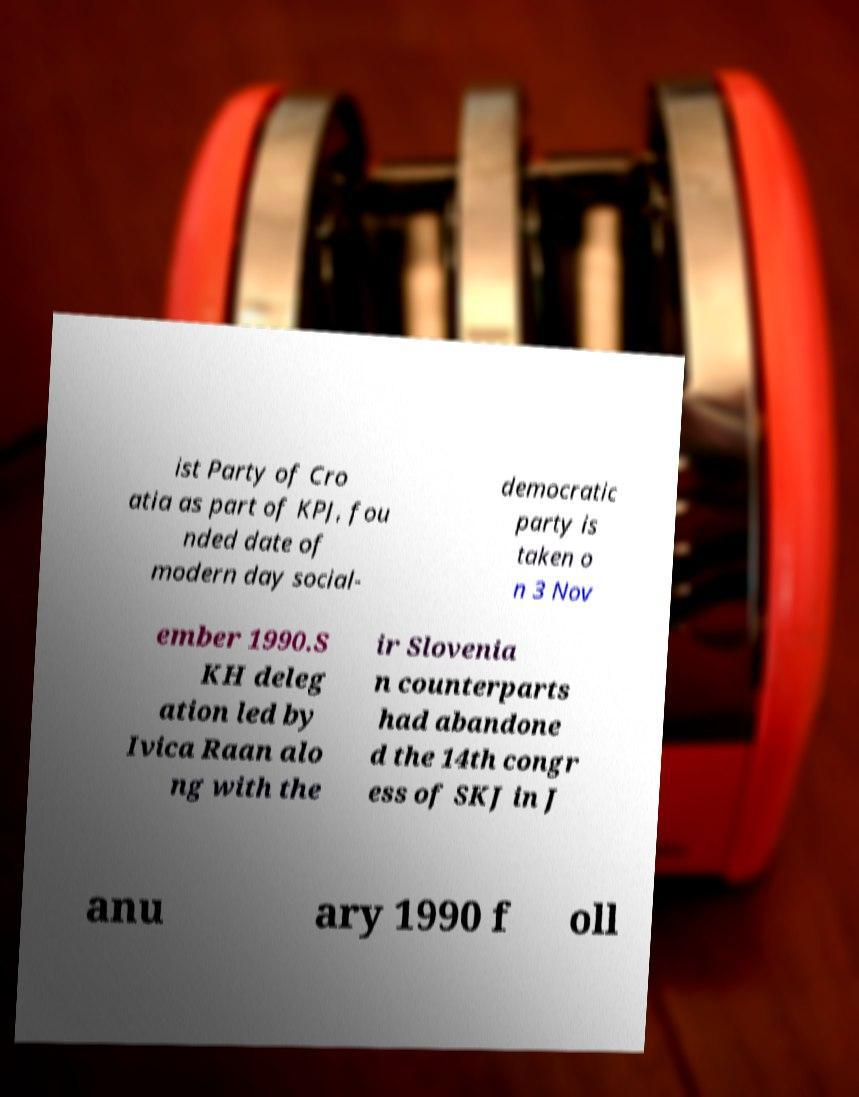I need the written content from this picture converted into text. Can you do that? ist Party of Cro atia as part of KPJ, fou nded date of modern day social- democratic party is taken o n 3 Nov ember 1990.S KH deleg ation led by Ivica Raan alo ng with the ir Slovenia n counterparts had abandone d the 14th congr ess of SKJ in J anu ary 1990 f oll 